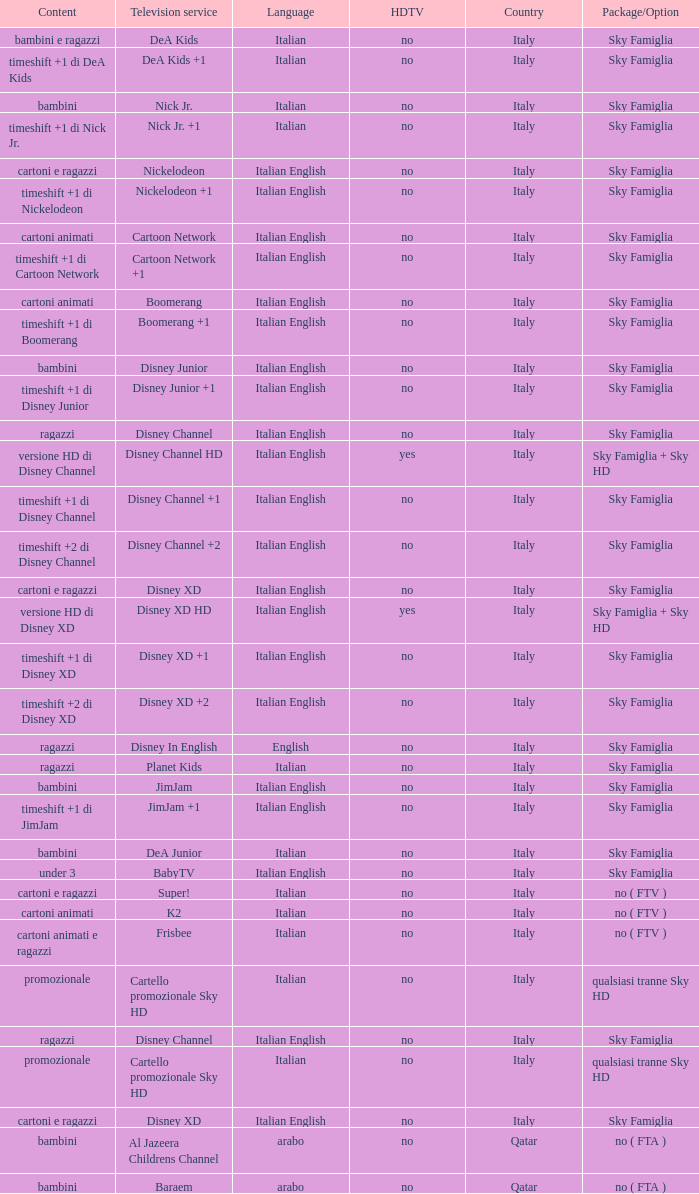What is the Country when the language is italian english, and the television service is disney xd +1? Italy. 